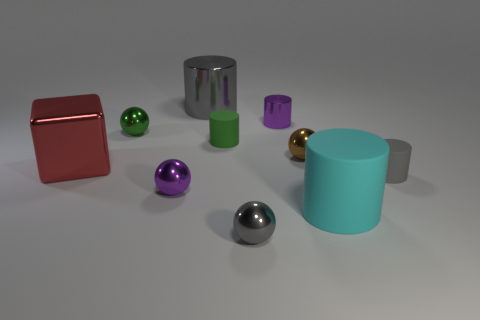How many objects are either green objects to the left of the large gray cylinder or gray matte cylinders?
Keep it short and to the point. 2. Are there the same number of purple balls in front of the large cyan cylinder and gray metal things?
Your answer should be compact. No. Is the size of the gray metal sphere the same as the brown object?
Offer a very short reply. Yes. The shiny cylinder that is the same size as the purple sphere is what color?
Provide a succinct answer. Purple. Does the cyan cylinder have the same size as the metal cylinder that is on the right side of the gray metal sphere?
Keep it short and to the point. No. How many other cylinders have the same color as the small metal cylinder?
Provide a short and direct response. 0. What number of things are either big objects or gray metal objects in front of the tiny green ball?
Provide a succinct answer. 4. Does the metal ball in front of the purple metal sphere have the same size as the thing behind the purple shiny cylinder?
Your answer should be very brief. No. Are there any big blue cylinders made of the same material as the large cyan cylinder?
Ensure brevity in your answer.  No. The green rubber thing is what shape?
Give a very brief answer. Cylinder. 